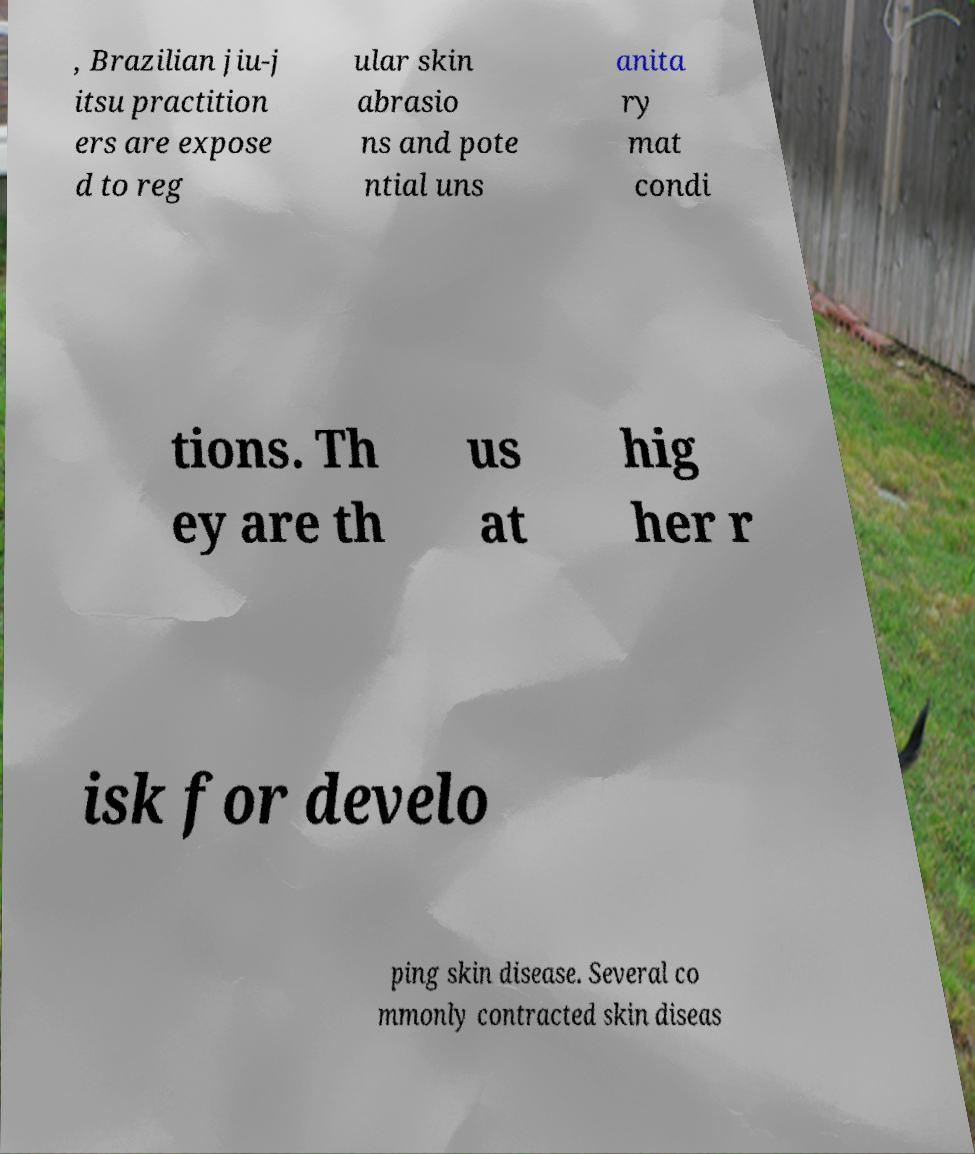Can you read and provide the text displayed in the image?This photo seems to have some interesting text. Can you extract and type it out for me? , Brazilian jiu-j itsu practition ers are expose d to reg ular skin abrasio ns and pote ntial uns anita ry mat condi tions. Th ey are th us at hig her r isk for develo ping skin disease. Several co mmonly contracted skin diseas 